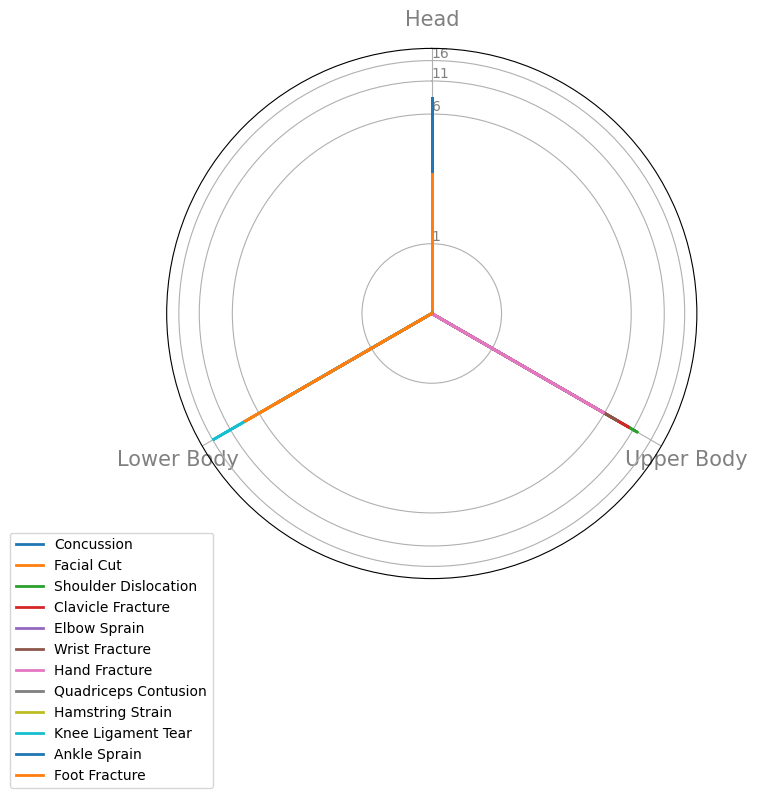What's the recovery rate for a concussion? To find the recovery rate for a concussion, look at the segment of the radar chart labeled "Head" and check the value corresponding to the concussion data point.
Answer: 8 weeks Which body part has the highest recovery rate for any injury type, and what's the rate? Scan through all the body parts on the radar chart and identify the highest value. The highest rate corresponds to "Knee Ligament Tear" under the "Lower Body" category.
Answer: Knee Ligament Tear, 16 weeks How does the recovery rate for a quadriceps contusion compare to an ankle sprain? Locate the values for both injuries in the "Lower Body" category on the radar chart. Quadriceps Contusion has a rate of 4 weeks and Ankle Sprain also has a rate of 4 weeks.
Answer: They are equal, 4 weeks What's the average recovery rate for upper body injuries? The upper body has 5 injuries with recovery rates of 12, 10, 6, 8, and 6 weeks respectively. Calculate the average: (12 + 10 + 6 + 8 + 6) / 5 = 42 / 5 = 8.4 weeks.
Answer: 8.4 weeks Which injury type has the lowest recovery rate, and what is it? Look for the lowest value on the radar chart across all body parts. The lowest value corresponds to "Facial Cut" under "Head."
Answer: Facial Cut, 2 weeks Compare the recovery rates for shoulder dislocation and clavicle fracture. What is the difference? Check the radar chart for shoulder dislocation and clavicle fracture under "Upper Body." Shoulder dislocation is 12 weeks and clavicle fracture is 10 weeks. Calculate the difference: 12 - 10 = 2 weeks.
Answer: 2 weeks What is the sum of recovery rates for all lower body injuries? The lower body has 5 injuries with recovery rates of 4, 6, 16, 4, and 8 weeks respectively. Calculate the sum: 4 + 6 + 16 + 4 + 8 = 38 weeks.
Answer: 38 weeks How many injury types have a recovery rate that exceeds 10 weeks? Identify the injury types on the radar chart with recovery rates above 10. These are Shoulder Dislocation and Knee Ligament Tear.
Answer: 2 injury types What's the average of the highest recovery rate and the lowest recovery rate identified in the radar chart? The highest recovery rate is 16 for Knee Ligament Tear, and the lowest is 2 for Facial Cut. Calculate the average: (16 + 2) / 2 = 18 / 2 = 9 weeks.
Answer: 9 weeks Which injury type in the "Head" body part category has a higher recovery rate? Look at the "Head" category in the radar chart for both the concussion and facial cut data points. Concussion has a rate of 8 weeks while facial cut has 2 weeks.
Answer: Concussion, 8 weeks 